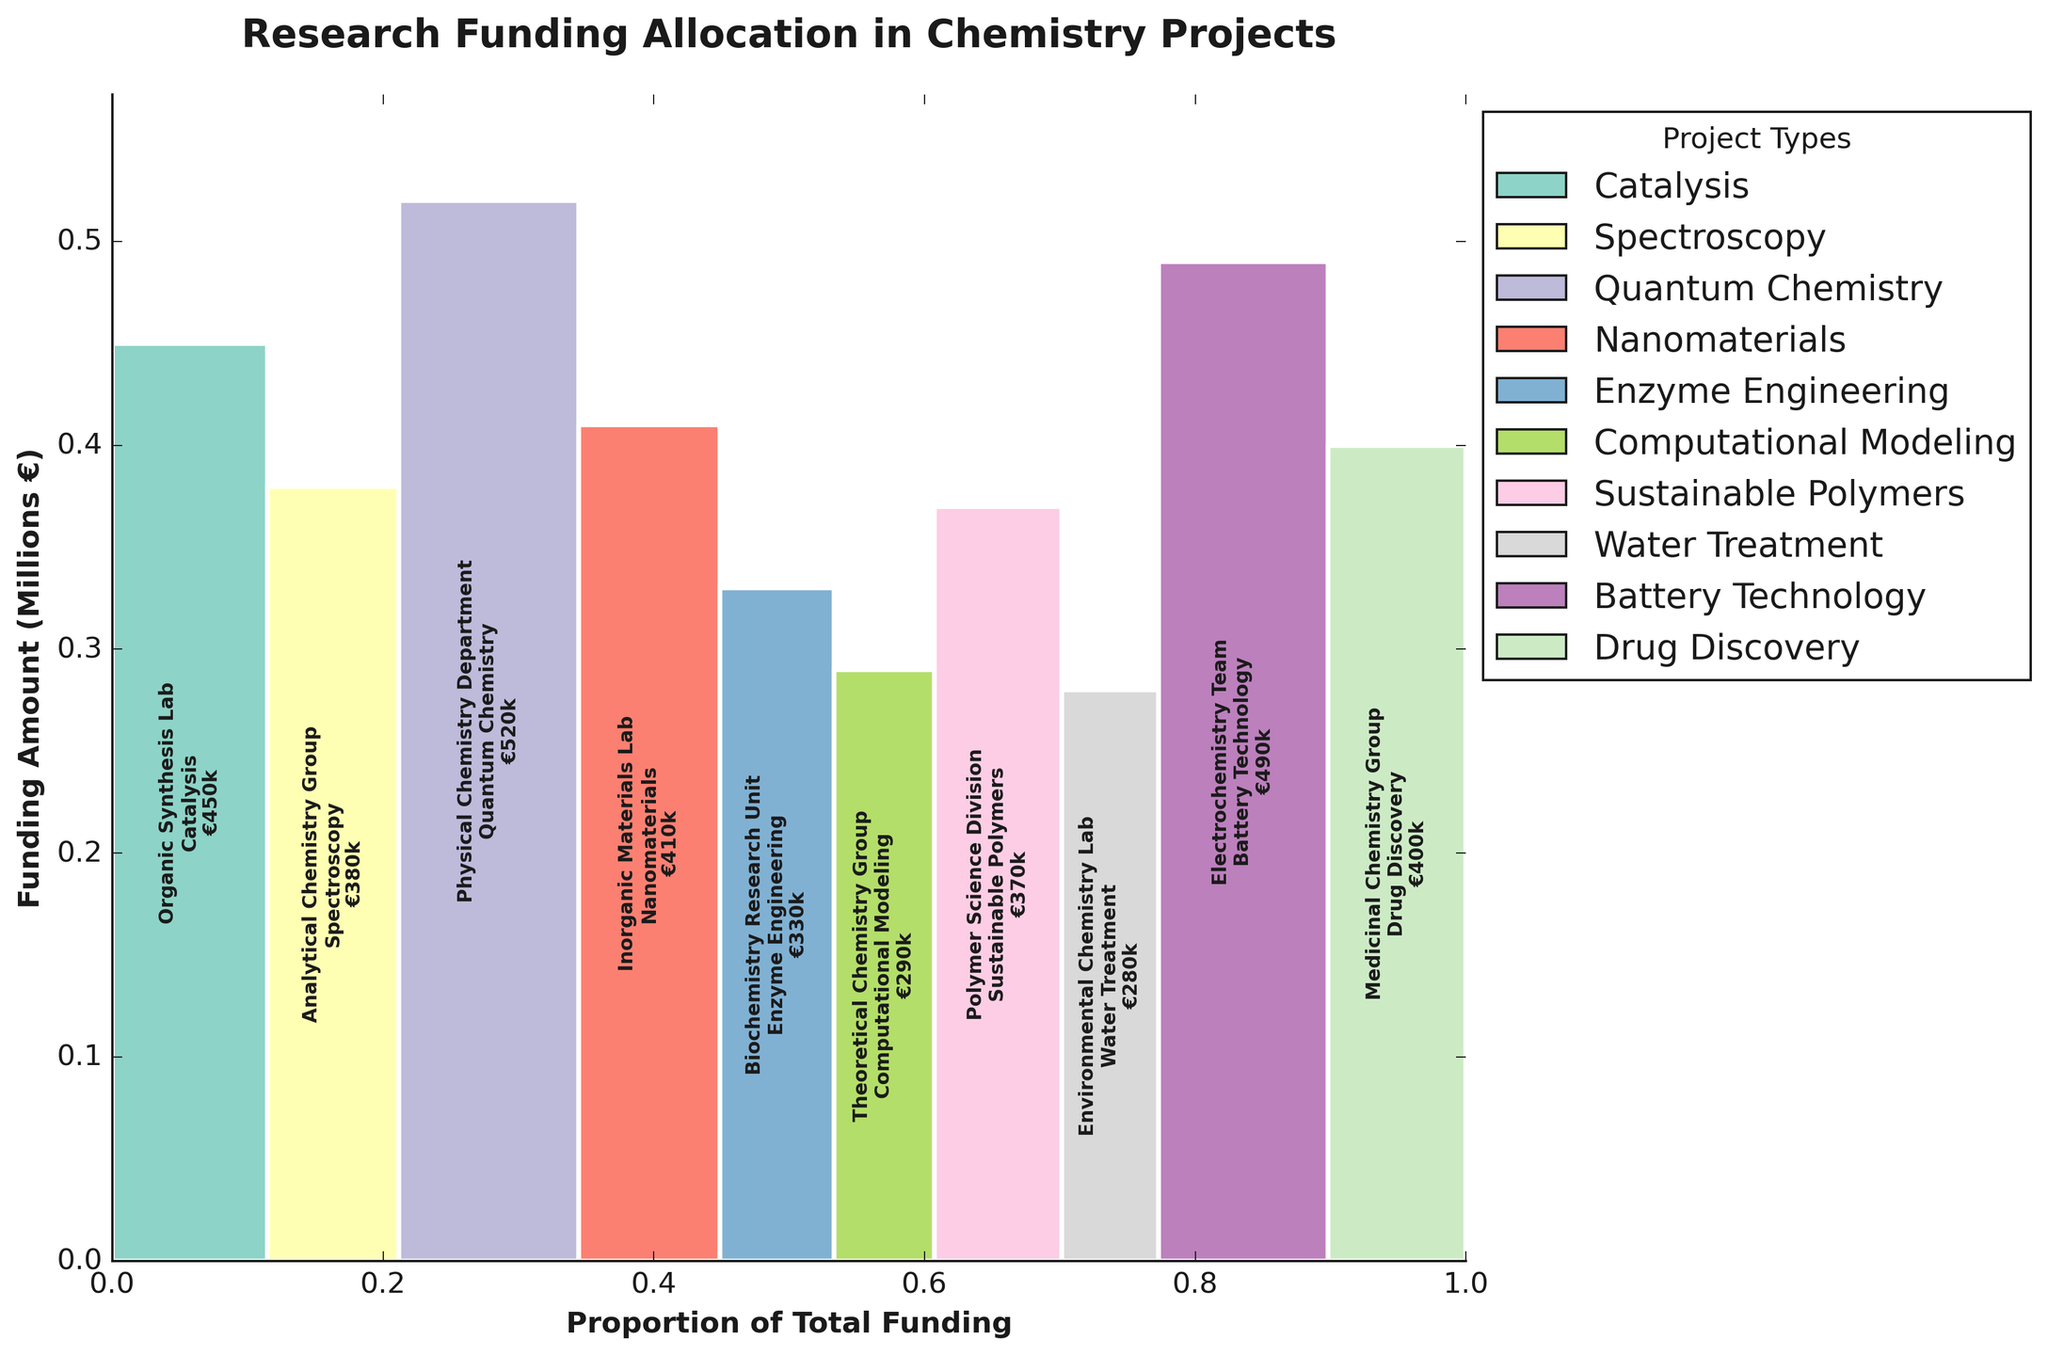What is the total funding amount allocated to the Drug Discovery project? Look for the bar labeled "Drug Discovery" in the figure. It is part of the Medicinal Chemistry Group. The funding amount for this project is indicated in the bar as €400000.
Answer: €400000 Which project received the highest funding amount? Find the tallest bar in the mosaic plot. The Physical Chemistry Department working on Quantum Chemistry received the most funding, which is €520000.
Answer: Quantum Chemistry How many research projects received funding amounts less than €350000? Identify the bars that have funding amounts labeled less than €350000. There are three such projects: Enzyme Engineering (€330000), Computational Modeling (€290000), and Water Treatment (€280000).
Answer: Three What is the total percentage of the budget allocated to the Organic Synthesis Lab and the Electrochemistry Team combined? Add the funding amounts for both labs: Organic Synthesis Lab (€450000) and Electrochemistry Team (€490000), totaling €940000. The total budget is €3920000. Compute the percentage: (€940000 / €3920000) * 100.
Answer: 24% Which project has a funding amount closest to the median value of all the projects? List the funding amounts and find the median value. Since there are 10 projects, find the 5th and 6th values when the amounts are sorted. The sorted amounts are: €280000, €290000, €330000, €370000, €380000, €400000, €410000, €450000, €490000, and €520000. The 5th and 6th values are €380000 and €400000, so the median is €390000. The closest project is Medicinal Chemistry Group's Drug Discovery at €400000.
Answer: Drug Discovery How does the funding of the Sustainable Polymers project compare to the Battery Technology project? Identify the funding amounts for both projects: Sustainable Polymers (€370000) and Battery Technology (€490000). Compare the values to see Sustainable Polymers received less funding than Battery Technology.
Answer: Less What is the ratio of the highest funding amount to the lowest funding amount? Determine the highest funding amount (€520000 for Quantum Chemistry) and the lowest (€280000 for Water Treatment). Calculate the ratio: (€520000 / €280000).
Answer: 1.857 Which research group works on the most diverse range of project types, based on the mosaic plot's legend? Observe the legend to see which research group appears to work on multiple project types. Each research group is associated with one project type in this plot, so no group works on the most diverse range of project types.
Answer: None What is the average amount of funding allocated per project? Sum the total funding amount (€3920000) and divide by the number of projects (10). The calculation is (€3920000 / 10).
Answer: €392000 Compare the funding allocated to Nanomaterials and Enzyme Engineering. Is the Nanomaterials project more heavily funded, and by how much? Identify the funding amounts for both projects: Nanomaterials (€410000) and Enzyme Engineering (€330000). Calculate the difference (€410000 - €330000).
Answer: €80000 